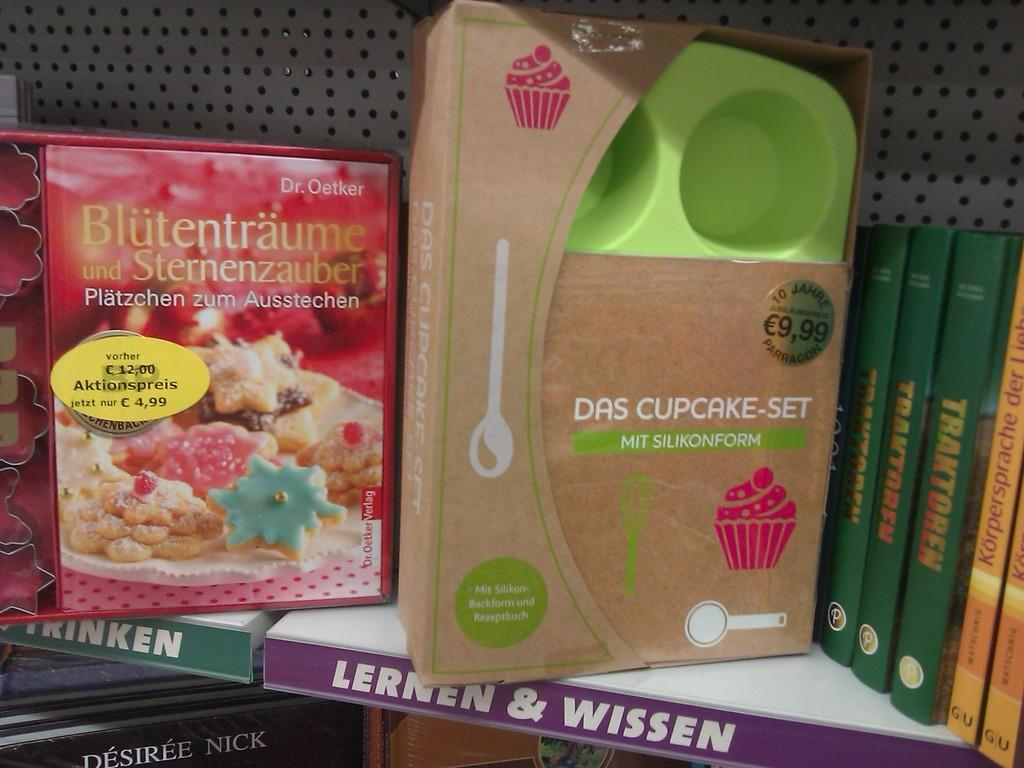<image>
Describe the image concisely. A shelf hold a Das Cupcake set and a cook book. 